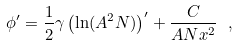<formula> <loc_0><loc_0><loc_500><loc_500>\phi ^ { \prime } = \frac { 1 } { 2 } \gamma \left ( \ln ( A ^ { 2 } N ) \right ) ^ { \prime } + \frac { C } { A N x ^ { 2 } } \ ,</formula> 